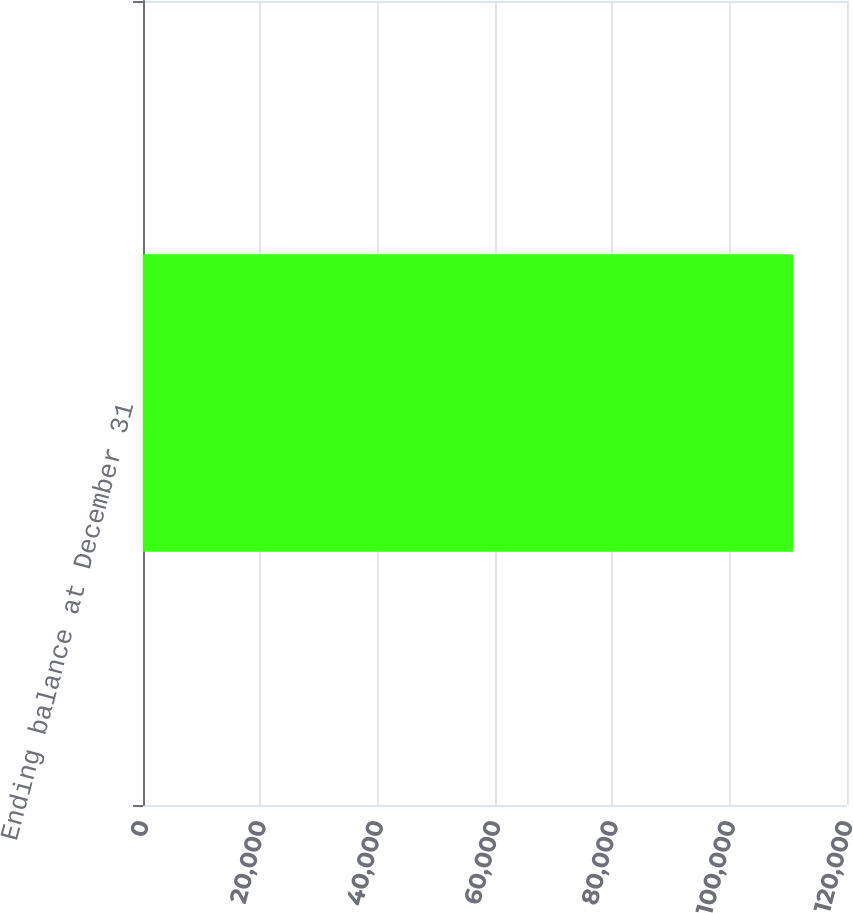Convert chart. <chart><loc_0><loc_0><loc_500><loc_500><bar_chart><fcel>Ending balance at December 31<nl><fcel>110883<nl></chart> 